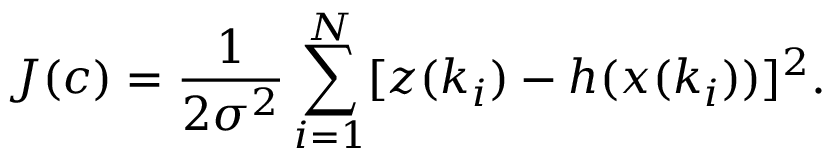<formula> <loc_0><loc_0><loc_500><loc_500>J ( c ) = \frac { 1 } { 2 \sigma ^ { 2 } } \sum _ { i = 1 } ^ { N } [ z ( k _ { i } ) - h ( x ( k _ { i } ) ) ] ^ { 2 } .</formula> 